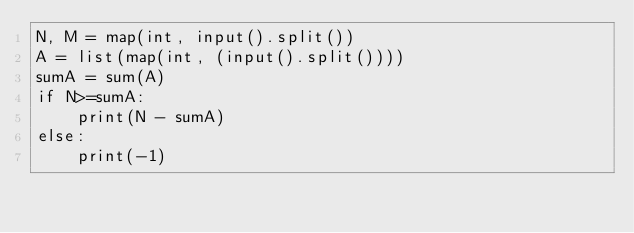<code> <loc_0><loc_0><loc_500><loc_500><_Python_>N, M = map(int, input().split())
A = list(map(int, (input().split())))
sumA = sum(A)
if N>=sumA:
    print(N - sumA)
else:
    print(-1)</code> 